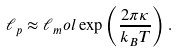<formula> <loc_0><loc_0><loc_500><loc_500>\ell _ { p } \approx \ell _ { m } o l \exp \left ( \frac { 2 \pi \kappa } { k _ { B } T } \right ) .</formula> 